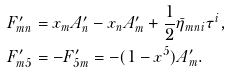Convert formula to latex. <formula><loc_0><loc_0><loc_500><loc_500>& F ^ { \prime } _ { m n } = x _ { m } A ^ { \prime } _ { n } - x _ { n } A ^ { \prime } _ { m } + \frac { 1 } { 2 } \bar { \eta } _ { m n i } \tau ^ { i } , \\ & F ^ { \prime } _ { m 5 } = - F ^ { \prime } _ { 5 m } = - ( 1 - x ^ { 5 } ) A ^ { \prime } _ { m } .</formula> 